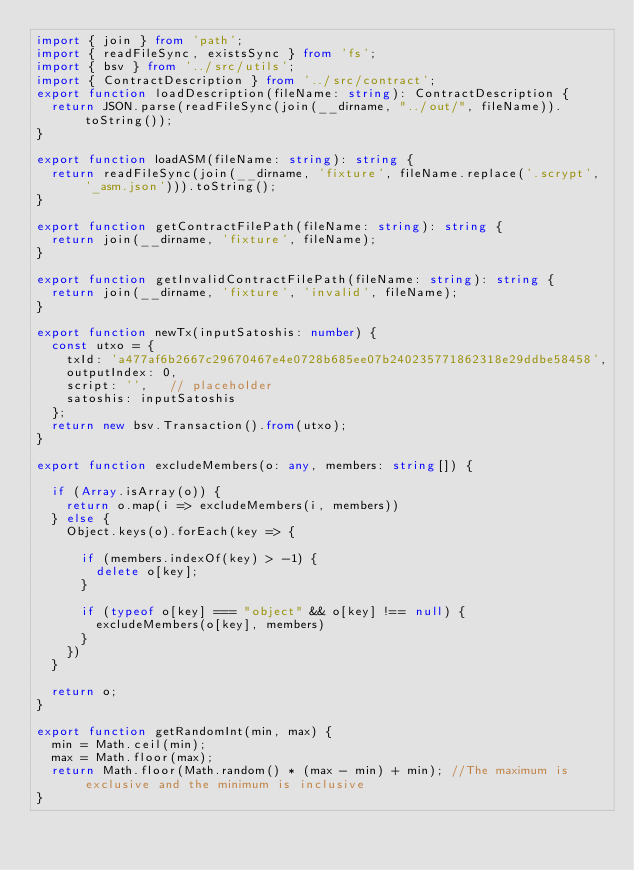<code> <loc_0><loc_0><loc_500><loc_500><_TypeScript_>import { join } from 'path';
import { readFileSync, existsSync } from 'fs';
import { bsv } from '../src/utils';
import { ContractDescription } from '../src/contract';
export function loadDescription(fileName: string): ContractDescription {
  return JSON.parse(readFileSync(join(__dirname, "../out/", fileName)).toString());
}

export function loadASM(fileName: string): string {
  return readFileSync(join(__dirname, 'fixture', fileName.replace('.scrypt', '_asm.json'))).toString();
}

export function getContractFilePath(fileName: string): string {
  return join(__dirname, 'fixture', fileName);
}

export function getInvalidContractFilePath(fileName: string): string {
  return join(__dirname, 'fixture', 'invalid', fileName);
}

export function newTx(inputSatoshis: number) {
  const utxo = {
    txId: 'a477af6b2667c29670467e4e0728b685ee07b240235771862318e29ddbe58458',
    outputIndex: 0,
    script: '',   // placeholder
    satoshis: inputSatoshis
  };
  return new bsv.Transaction().from(utxo);
}

export function excludeMembers(o: any, members: string[]) {

  if (Array.isArray(o)) {
    return o.map(i => excludeMembers(i, members))
  } else {
    Object.keys(o).forEach(key => {

      if (members.indexOf(key) > -1) {
        delete o[key];
      }

      if (typeof o[key] === "object" && o[key] !== null) {
        excludeMembers(o[key], members)
      }
    })
  }

  return o;
}

export function getRandomInt(min, max) {
  min = Math.ceil(min);
  max = Math.floor(max);
  return Math.floor(Math.random() * (max - min) + min); //The maximum is exclusive and the minimum is inclusive
}
</code> 